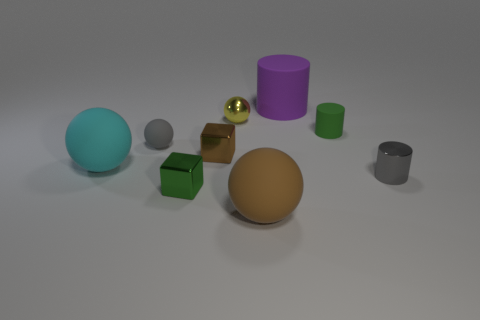What is the material of the tiny gray cylinder?
Offer a terse response. Metal. There is a large brown rubber sphere; what number of brown metal things are right of it?
Your answer should be compact. 0. Is the big cylinder the same color as the metal cylinder?
Provide a short and direct response. No. What number of large matte objects are the same color as the small metal sphere?
Provide a short and direct response. 0. Is the number of gray metal objects greater than the number of tiny cyan metallic cubes?
Ensure brevity in your answer.  Yes. There is a ball that is both on the right side of the small green cube and behind the small gray shiny cylinder; what is its size?
Make the answer very short. Small. Are the tiny brown object right of the cyan matte sphere and the green thing that is right of the large purple rubber object made of the same material?
Keep it short and to the point. No. What is the shape of the purple matte thing that is the same size as the brown rubber object?
Give a very brief answer. Cylinder. Are there fewer large green rubber things than brown metal things?
Give a very brief answer. Yes. There is a green object right of the large brown rubber sphere; are there any gray metallic things that are behind it?
Your answer should be compact. No. 